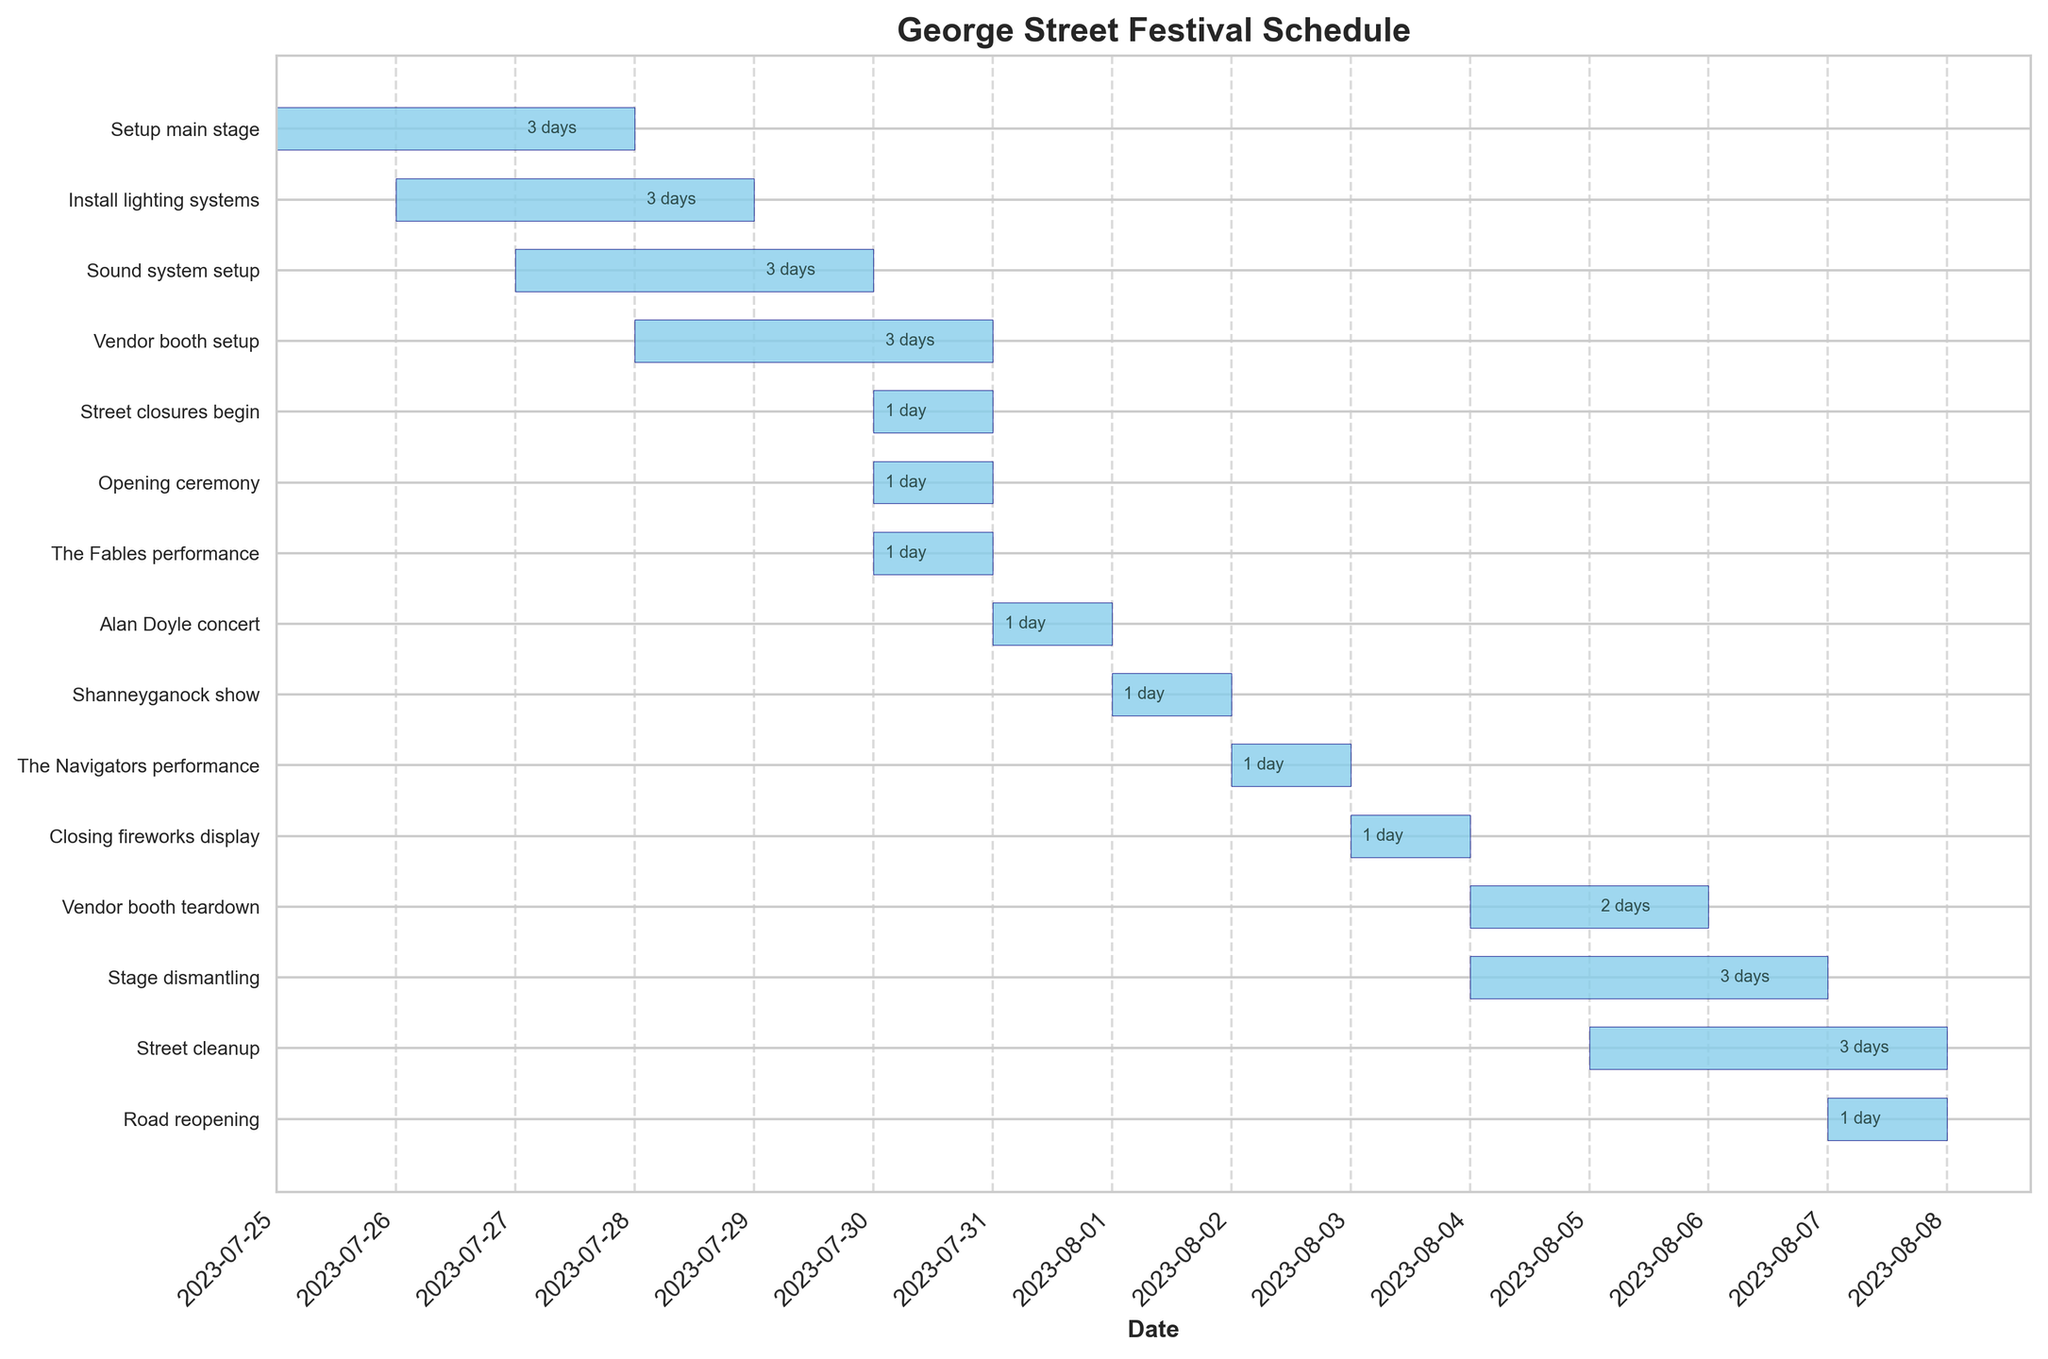what's the title of the Gantt Chart? The title is located at the top of the Gantt Chart.
Answer: George Street Festival Schedule which activities occur on the first day, July 25th, 2023? Locate July 25th, 2023 on the x-axis and identify the activities starting on that date.
Answer: Setup main stage how many days does the Setup main stage task take? Use the duration labeled on the bar for Setup main stage. It starts on July 25 and ends on July 27.
Answer: 3 days which task immediately follows the Setup main stage? Identify the task that starts right after the Setup main stage ends on July 27.
Answer: Sound system setup how long is the entire festival period, from the first setup to the end of cleanup and road reopening? Identify the start date of the first task (Setup main stage on July 25) and the end date of the last task (Road reopening on August 7), then calculate the total number of days.
Answer: 14 days how many performances occur during the festival? Look at the tasks labeled as performances, and count them.
Answer: 4 performances which task has the shortest duration and how long is it? Compare the durations of all tasks and find the one with the minimum number of days.
Answer: Multiple tasks, 1 day which tasks are conducted on the same day as the closing fireworks display? Locate the date of the closing fireworks display on the chart and find other tasks occurring on the same day.
Answer: Closing fireworks display only during which date range does the Vendor booth setup occur? Look at the start and end dates for the Vendor booth setup task.
Answer: July 28 to July 30 how does the duration of Street cleanup compare to that of Vendor booth teardown? Identify the durations of both tasks and compare them.
Answer: Street cleanup is longer (3 days vs. 2 days) 